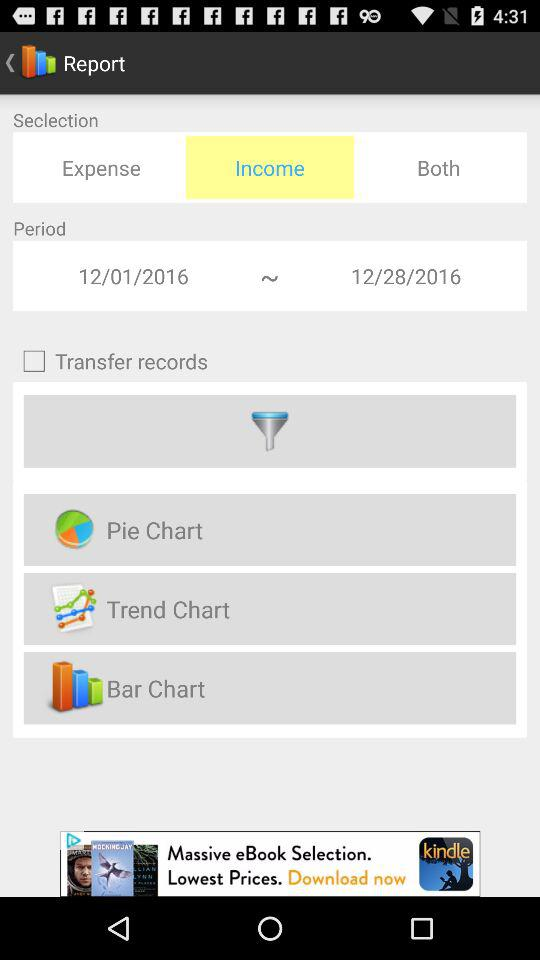Is transfer records selected or not?
When the provided information is insufficient, respond with <no answer>. <no answer> 